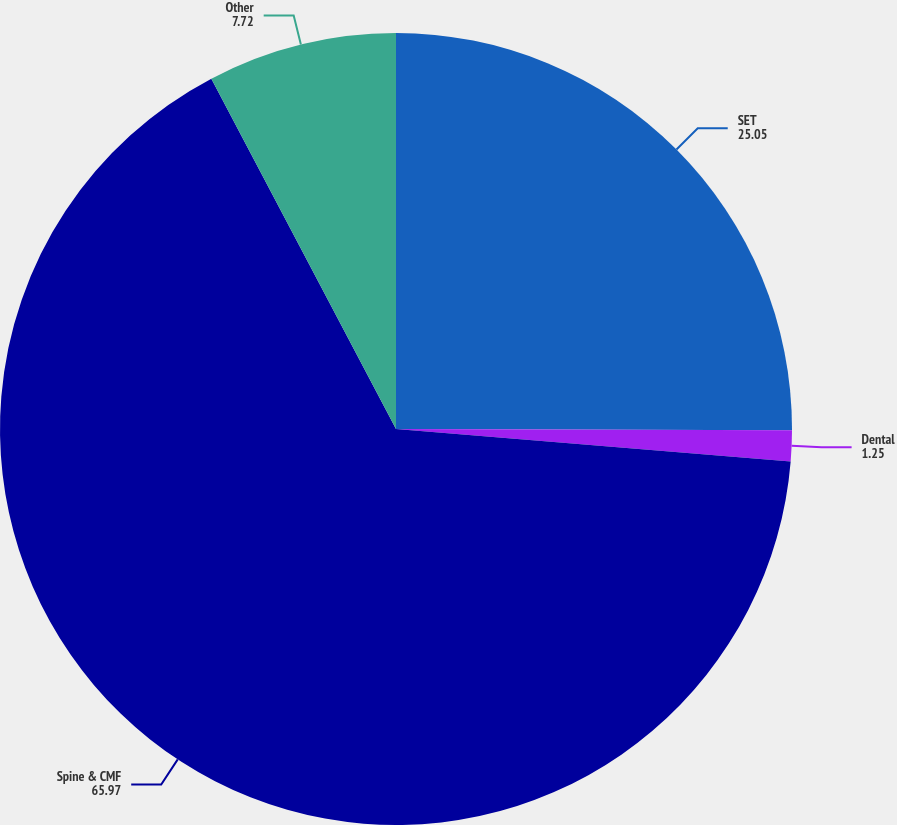Convert chart to OTSL. <chart><loc_0><loc_0><loc_500><loc_500><pie_chart><fcel>SET<fcel>Dental<fcel>Spine & CMF<fcel>Other<nl><fcel>25.05%<fcel>1.25%<fcel>65.97%<fcel>7.72%<nl></chart> 